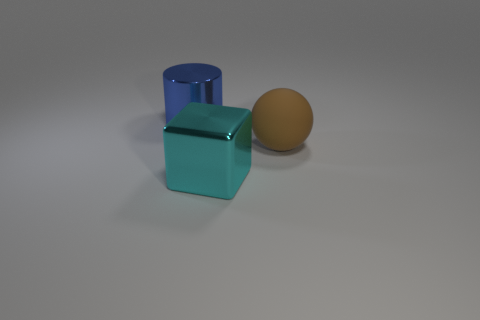Is the number of cylinders less than the number of red objects?
Make the answer very short. No. Are there any other things that are the same color as the metallic cylinder?
Provide a short and direct response. No. The large cyan thing that is made of the same material as the large blue thing is what shape?
Provide a succinct answer. Cube. What number of large blue metal cylinders are left of the large object that is right of the cyan cube in front of the brown sphere?
Give a very brief answer. 1. What shape is the large object that is both behind the cyan block and on the left side of the big brown rubber object?
Offer a terse response. Cylinder. Is the number of cyan metal things that are left of the shiny cube less than the number of blue metallic things?
Provide a short and direct response. Yes. How many small objects are either gray cylinders or cyan blocks?
Make the answer very short. 0. What size is the cyan metal block?
Make the answer very short. Large. Is there anything else that is made of the same material as the large brown sphere?
Your response must be concise. No. What number of large blue metal cylinders are behind the large blue cylinder?
Ensure brevity in your answer.  0. 